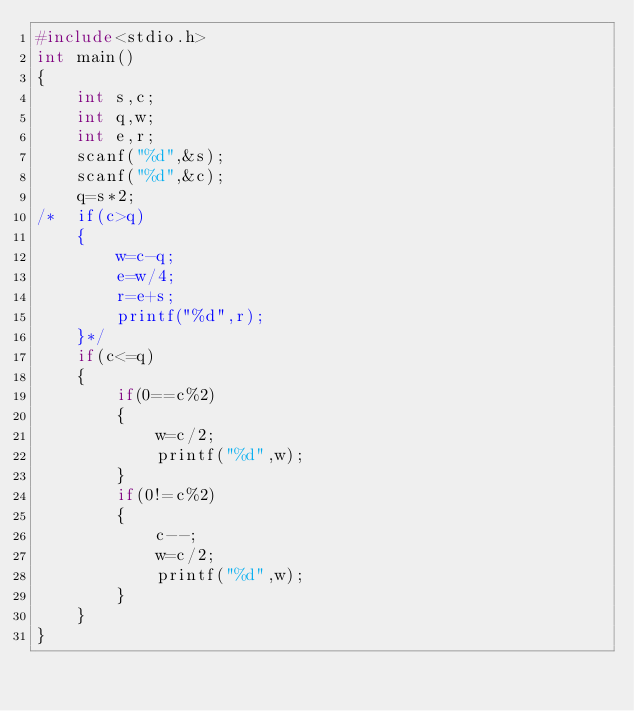<code> <loc_0><loc_0><loc_500><loc_500><_C_>#include<stdio.h>
int main()
{
	int s,c;
	int q,w;
	int e,r;
	scanf("%d",&s);
	scanf("%d",&c);
	q=s*2;
/*	if(c>q)
	{
		w=c-q;
		e=w/4;
		r=e+s;
		printf("%d",r);
	}*/
	if(c<=q)
	{
		if(0==c%2)
		{
			w=c/2;
			printf("%d",w);
		}
		if(0!=c%2)
		{
			c--;
			w=c/2;
			printf("%d",w);
		}
	}
}</code> 